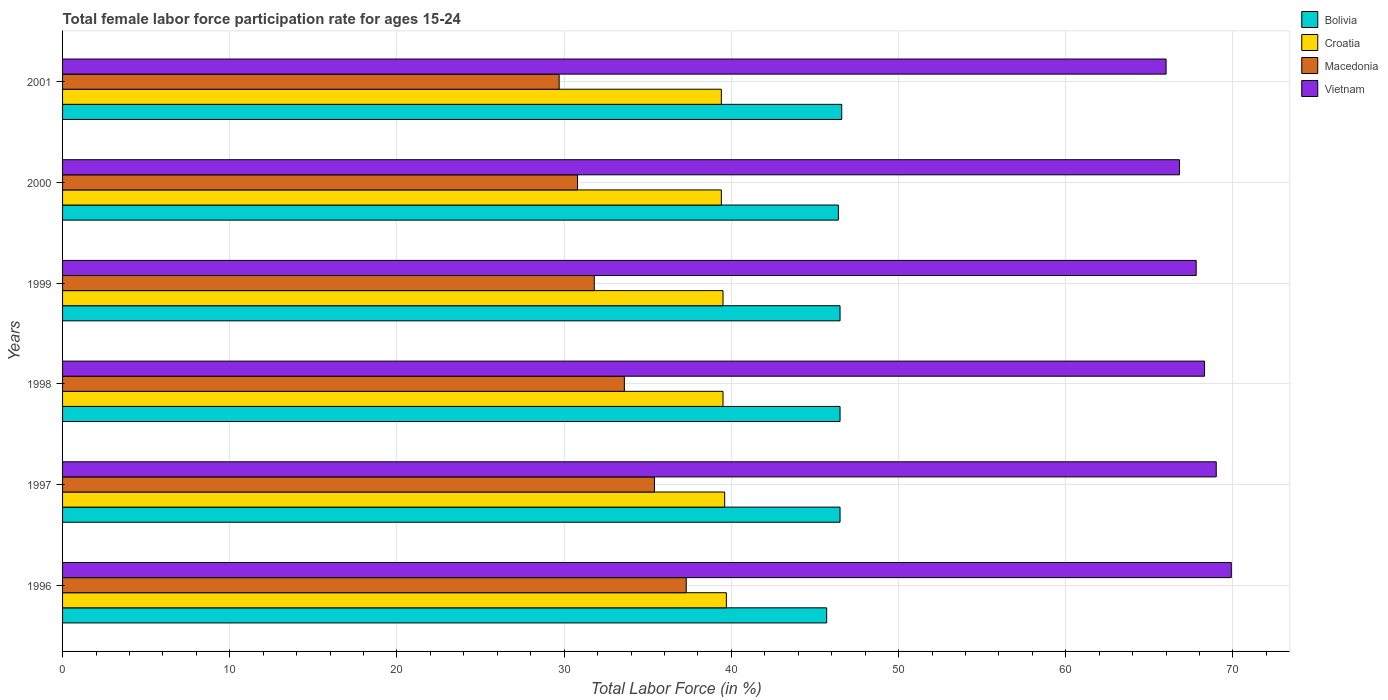How many groups of bars are there?
Provide a short and direct response. 6. Are the number of bars per tick equal to the number of legend labels?
Your answer should be compact. Yes. Are the number of bars on each tick of the Y-axis equal?
Offer a terse response. Yes. What is the female labor force participation rate in Macedonia in 1998?
Offer a very short reply. 33.6. Across all years, what is the maximum female labor force participation rate in Bolivia?
Offer a very short reply. 46.6. Across all years, what is the minimum female labor force participation rate in Bolivia?
Give a very brief answer. 45.7. In which year was the female labor force participation rate in Bolivia minimum?
Your response must be concise. 1996. What is the total female labor force participation rate in Vietnam in the graph?
Offer a very short reply. 407.8. What is the difference between the female labor force participation rate in Vietnam in 1997 and that in 2000?
Give a very brief answer. 2.2. What is the difference between the female labor force participation rate in Macedonia in 1997 and the female labor force participation rate in Bolivia in 1998?
Offer a terse response. -11.1. What is the average female labor force participation rate in Bolivia per year?
Offer a very short reply. 46.37. In the year 2000, what is the difference between the female labor force participation rate in Macedonia and female labor force participation rate in Bolivia?
Make the answer very short. -15.6. What is the ratio of the female labor force participation rate in Vietnam in 1997 to that in 1998?
Provide a succinct answer. 1.01. What is the difference between the highest and the second highest female labor force participation rate in Macedonia?
Give a very brief answer. 1.9. What is the difference between the highest and the lowest female labor force participation rate in Vietnam?
Provide a short and direct response. 3.9. In how many years, is the female labor force participation rate in Croatia greater than the average female labor force participation rate in Croatia taken over all years?
Provide a short and direct response. 2. Is the sum of the female labor force participation rate in Vietnam in 1996 and 1999 greater than the maximum female labor force participation rate in Macedonia across all years?
Offer a terse response. Yes. Is it the case that in every year, the sum of the female labor force participation rate in Bolivia and female labor force participation rate in Macedonia is greater than the sum of female labor force participation rate in Croatia and female labor force participation rate in Vietnam?
Keep it short and to the point. No. What does the 1st bar from the top in 1999 represents?
Provide a short and direct response. Vietnam. What does the 3rd bar from the bottom in 1996 represents?
Keep it short and to the point. Macedonia. How many bars are there?
Your answer should be very brief. 24. Are all the bars in the graph horizontal?
Provide a succinct answer. Yes. What is the difference between two consecutive major ticks on the X-axis?
Your response must be concise. 10. What is the title of the graph?
Offer a terse response. Total female labor force participation rate for ages 15-24. What is the label or title of the Y-axis?
Your response must be concise. Years. What is the Total Labor Force (in %) of Bolivia in 1996?
Your response must be concise. 45.7. What is the Total Labor Force (in %) of Croatia in 1996?
Make the answer very short. 39.7. What is the Total Labor Force (in %) in Macedonia in 1996?
Offer a very short reply. 37.3. What is the Total Labor Force (in %) of Vietnam in 1996?
Offer a very short reply. 69.9. What is the Total Labor Force (in %) of Bolivia in 1997?
Your answer should be compact. 46.5. What is the Total Labor Force (in %) of Croatia in 1997?
Your answer should be compact. 39.6. What is the Total Labor Force (in %) of Macedonia in 1997?
Your response must be concise. 35.4. What is the Total Labor Force (in %) of Vietnam in 1997?
Offer a terse response. 69. What is the Total Labor Force (in %) of Bolivia in 1998?
Provide a short and direct response. 46.5. What is the Total Labor Force (in %) in Croatia in 1998?
Keep it short and to the point. 39.5. What is the Total Labor Force (in %) in Macedonia in 1998?
Provide a short and direct response. 33.6. What is the Total Labor Force (in %) in Vietnam in 1998?
Your answer should be very brief. 68.3. What is the Total Labor Force (in %) in Bolivia in 1999?
Provide a succinct answer. 46.5. What is the Total Labor Force (in %) in Croatia in 1999?
Keep it short and to the point. 39.5. What is the Total Labor Force (in %) in Macedonia in 1999?
Your answer should be very brief. 31.8. What is the Total Labor Force (in %) of Vietnam in 1999?
Your answer should be very brief. 67.8. What is the Total Labor Force (in %) of Bolivia in 2000?
Give a very brief answer. 46.4. What is the Total Labor Force (in %) of Croatia in 2000?
Give a very brief answer. 39.4. What is the Total Labor Force (in %) in Macedonia in 2000?
Your answer should be very brief. 30.8. What is the Total Labor Force (in %) of Vietnam in 2000?
Offer a terse response. 66.8. What is the Total Labor Force (in %) in Bolivia in 2001?
Your answer should be very brief. 46.6. What is the Total Labor Force (in %) of Croatia in 2001?
Make the answer very short. 39.4. What is the Total Labor Force (in %) in Macedonia in 2001?
Offer a very short reply. 29.7. Across all years, what is the maximum Total Labor Force (in %) of Bolivia?
Provide a succinct answer. 46.6. Across all years, what is the maximum Total Labor Force (in %) in Croatia?
Make the answer very short. 39.7. Across all years, what is the maximum Total Labor Force (in %) in Macedonia?
Give a very brief answer. 37.3. Across all years, what is the maximum Total Labor Force (in %) of Vietnam?
Your answer should be very brief. 69.9. Across all years, what is the minimum Total Labor Force (in %) of Bolivia?
Offer a very short reply. 45.7. Across all years, what is the minimum Total Labor Force (in %) in Croatia?
Offer a very short reply. 39.4. Across all years, what is the minimum Total Labor Force (in %) in Macedonia?
Give a very brief answer. 29.7. Across all years, what is the minimum Total Labor Force (in %) in Vietnam?
Provide a succinct answer. 66. What is the total Total Labor Force (in %) of Bolivia in the graph?
Your answer should be compact. 278.2. What is the total Total Labor Force (in %) in Croatia in the graph?
Ensure brevity in your answer.  237.1. What is the total Total Labor Force (in %) of Macedonia in the graph?
Offer a terse response. 198.6. What is the total Total Labor Force (in %) of Vietnam in the graph?
Ensure brevity in your answer.  407.8. What is the difference between the Total Labor Force (in %) of Bolivia in 1996 and that in 1997?
Give a very brief answer. -0.8. What is the difference between the Total Labor Force (in %) of Croatia in 1996 and that in 1997?
Keep it short and to the point. 0.1. What is the difference between the Total Labor Force (in %) of Bolivia in 1996 and that in 1998?
Ensure brevity in your answer.  -0.8. What is the difference between the Total Labor Force (in %) in Croatia in 1996 and that in 1999?
Provide a short and direct response. 0.2. What is the difference between the Total Labor Force (in %) of Macedonia in 1996 and that in 1999?
Your answer should be very brief. 5.5. What is the difference between the Total Labor Force (in %) in Bolivia in 1996 and that in 2000?
Give a very brief answer. -0.7. What is the difference between the Total Labor Force (in %) in Croatia in 1996 and that in 2000?
Make the answer very short. 0.3. What is the difference between the Total Labor Force (in %) in Macedonia in 1996 and that in 2000?
Provide a succinct answer. 6.5. What is the difference between the Total Labor Force (in %) in Vietnam in 1996 and that in 2000?
Give a very brief answer. 3.1. What is the difference between the Total Labor Force (in %) in Bolivia in 1996 and that in 2001?
Keep it short and to the point. -0.9. What is the difference between the Total Labor Force (in %) of Croatia in 1997 and that in 1998?
Offer a terse response. 0.1. What is the difference between the Total Labor Force (in %) in Vietnam in 1997 and that in 1998?
Offer a very short reply. 0.7. What is the difference between the Total Labor Force (in %) of Bolivia in 1997 and that in 1999?
Your response must be concise. 0. What is the difference between the Total Labor Force (in %) in Croatia in 1997 and that in 1999?
Your answer should be very brief. 0.1. What is the difference between the Total Labor Force (in %) of Macedonia in 1997 and that in 1999?
Make the answer very short. 3.6. What is the difference between the Total Labor Force (in %) in Vietnam in 1997 and that in 2000?
Offer a very short reply. 2.2. What is the difference between the Total Labor Force (in %) of Bolivia in 1997 and that in 2001?
Keep it short and to the point. -0.1. What is the difference between the Total Labor Force (in %) in Croatia in 1997 and that in 2001?
Make the answer very short. 0.2. What is the difference between the Total Labor Force (in %) of Macedonia in 1997 and that in 2001?
Keep it short and to the point. 5.7. What is the difference between the Total Labor Force (in %) of Croatia in 1998 and that in 1999?
Provide a succinct answer. 0. What is the difference between the Total Labor Force (in %) in Macedonia in 1998 and that in 1999?
Ensure brevity in your answer.  1.8. What is the difference between the Total Labor Force (in %) in Vietnam in 1998 and that in 1999?
Keep it short and to the point. 0.5. What is the difference between the Total Labor Force (in %) in Bolivia in 1998 and that in 2001?
Offer a very short reply. -0.1. What is the difference between the Total Labor Force (in %) in Croatia in 1998 and that in 2001?
Give a very brief answer. 0.1. What is the difference between the Total Labor Force (in %) in Bolivia in 1999 and that in 2000?
Keep it short and to the point. 0.1. What is the difference between the Total Labor Force (in %) in Macedonia in 1999 and that in 2000?
Ensure brevity in your answer.  1. What is the difference between the Total Labor Force (in %) of Vietnam in 1999 and that in 2000?
Provide a short and direct response. 1. What is the difference between the Total Labor Force (in %) in Croatia in 2000 and that in 2001?
Make the answer very short. 0. What is the difference between the Total Labor Force (in %) of Macedonia in 2000 and that in 2001?
Your response must be concise. 1.1. What is the difference between the Total Labor Force (in %) of Bolivia in 1996 and the Total Labor Force (in %) of Vietnam in 1997?
Provide a short and direct response. -23.3. What is the difference between the Total Labor Force (in %) of Croatia in 1996 and the Total Labor Force (in %) of Macedonia in 1997?
Make the answer very short. 4.3. What is the difference between the Total Labor Force (in %) in Croatia in 1996 and the Total Labor Force (in %) in Vietnam in 1997?
Give a very brief answer. -29.3. What is the difference between the Total Labor Force (in %) of Macedonia in 1996 and the Total Labor Force (in %) of Vietnam in 1997?
Your answer should be very brief. -31.7. What is the difference between the Total Labor Force (in %) of Bolivia in 1996 and the Total Labor Force (in %) of Croatia in 1998?
Give a very brief answer. 6.2. What is the difference between the Total Labor Force (in %) in Bolivia in 1996 and the Total Labor Force (in %) in Vietnam in 1998?
Offer a very short reply. -22.6. What is the difference between the Total Labor Force (in %) of Croatia in 1996 and the Total Labor Force (in %) of Vietnam in 1998?
Keep it short and to the point. -28.6. What is the difference between the Total Labor Force (in %) in Macedonia in 1996 and the Total Labor Force (in %) in Vietnam in 1998?
Your response must be concise. -31. What is the difference between the Total Labor Force (in %) of Bolivia in 1996 and the Total Labor Force (in %) of Macedonia in 1999?
Your answer should be very brief. 13.9. What is the difference between the Total Labor Force (in %) in Bolivia in 1996 and the Total Labor Force (in %) in Vietnam in 1999?
Provide a short and direct response. -22.1. What is the difference between the Total Labor Force (in %) of Croatia in 1996 and the Total Labor Force (in %) of Vietnam in 1999?
Provide a succinct answer. -28.1. What is the difference between the Total Labor Force (in %) of Macedonia in 1996 and the Total Labor Force (in %) of Vietnam in 1999?
Your response must be concise. -30.5. What is the difference between the Total Labor Force (in %) in Bolivia in 1996 and the Total Labor Force (in %) in Croatia in 2000?
Offer a very short reply. 6.3. What is the difference between the Total Labor Force (in %) in Bolivia in 1996 and the Total Labor Force (in %) in Macedonia in 2000?
Provide a short and direct response. 14.9. What is the difference between the Total Labor Force (in %) of Bolivia in 1996 and the Total Labor Force (in %) of Vietnam in 2000?
Offer a very short reply. -21.1. What is the difference between the Total Labor Force (in %) of Croatia in 1996 and the Total Labor Force (in %) of Vietnam in 2000?
Provide a short and direct response. -27.1. What is the difference between the Total Labor Force (in %) of Macedonia in 1996 and the Total Labor Force (in %) of Vietnam in 2000?
Provide a succinct answer. -29.5. What is the difference between the Total Labor Force (in %) in Bolivia in 1996 and the Total Labor Force (in %) in Croatia in 2001?
Provide a succinct answer. 6.3. What is the difference between the Total Labor Force (in %) in Bolivia in 1996 and the Total Labor Force (in %) in Macedonia in 2001?
Provide a succinct answer. 16. What is the difference between the Total Labor Force (in %) of Bolivia in 1996 and the Total Labor Force (in %) of Vietnam in 2001?
Your answer should be compact. -20.3. What is the difference between the Total Labor Force (in %) of Croatia in 1996 and the Total Labor Force (in %) of Macedonia in 2001?
Ensure brevity in your answer.  10. What is the difference between the Total Labor Force (in %) in Croatia in 1996 and the Total Labor Force (in %) in Vietnam in 2001?
Keep it short and to the point. -26.3. What is the difference between the Total Labor Force (in %) of Macedonia in 1996 and the Total Labor Force (in %) of Vietnam in 2001?
Your answer should be very brief. -28.7. What is the difference between the Total Labor Force (in %) in Bolivia in 1997 and the Total Labor Force (in %) in Vietnam in 1998?
Ensure brevity in your answer.  -21.8. What is the difference between the Total Labor Force (in %) in Croatia in 1997 and the Total Labor Force (in %) in Vietnam in 1998?
Provide a short and direct response. -28.7. What is the difference between the Total Labor Force (in %) of Macedonia in 1997 and the Total Labor Force (in %) of Vietnam in 1998?
Offer a very short reply. -32.9. What is the difference between the Total Labor Force (in %) of Bolivia in 1997 and the Total Labor Force (in %) of Croatia in 1999?
Offer a terse response. 7. What is the difference between the Total Labor Force (in %) in Bolivia in 1997 and the Total Labor Force (in %) in Macedonia in 1999?
Your response must be concise. 14.7. What is the difference between the Total Labor Force (in %) in Bolivia in 1997 and the Total Labor Force (in %) in Vietnam in 1999?
Give a very brief answer. -21.3. What is the difference between the Total Labor Force (in %) of Croatia in 1997 and the Total Labor Force (in %) of Vietnam in 1999?
Provide a short and direct response. -28.2. What is the difference between the Total Labor Force (in %) of Macedonia in 1997 and the Total Labor Force (in %) of Vietnam in 1999?
Give a very brief answer. -32.4. What is the difference between the Total Labor Force (in %) in Bolivia in 1997 and the Total Labor Force (in %) in Macedonia in 2000?
Your response must be concise. 15.7. What is the difference between the Total Labor Force (in %) in Bolivia in 1997 and the Total Labor Force (in %) in Vietnam in 2000?
Provide a succinct answer. -20.3. What is the difference between the Total Labor Force (in %) of Croatia in 1997 and the Total Labor Force (in %) of Macedonia in 2000?
Your answer should be very brief. 8.8. What is the difference between the Total Labor Force (in %) of Croatia in 1997 and the Total Labor Force (in %) of Vietnam in 2000?
Keep it short and to the point. -27.2. What is the difference between the Total Labor Force (in %) of Macedonia in 1997 and the Total Labor Force (in %) of Vietnam in 2000?
Keep it short and to the point. -31.4. What is the difference between the Total Labor Force (in %) of Bolivia in 1997 and the Total Labor Force (in %) of Croatia in 2001?
Provide a succinct answer. 7.1. What is the difference between the Total Labor Force (in %) of Bolivia in 1997 and the Total Labor Force (in %) of Macedonia in 2001?
Keep it short and to the point. 16.8. What is the difference between the Total Labor Force (in %) in Bolivia in 1997 and the Total Labor Force (in %) in Vietnam in 2001?
Ensure brevity in your answer.  -19.5. What is the difference between the Total Labor Force (in %) in Croatia in 1997 and the Total Labor Force (in %) in Macedonia in 2001?
Keep it short and to the point. 9.9. What is the difference between the Total Labor Force (in %) of Croatia in 1997 and the Total Labor Force (in %) of Vietnam in 2001?
Provide a short and direct response. -26.4. What is the difference between the Total Labor Force (in %) of Macedonia in 1997 and the Total Labor Force (in %) of Vietnam in 2001?
Your response must be concise. -30.6. What is the difference between the Total Labor Force (in %) of Bolivia in 1998 and the Total Labor Force (in %) of Croatia in 1999?
Your response must be concise. 7. What is the difference between the Total Labor Force (in %) of Bolivia in 1998 and the Total Labor Force (in %) of Macedonia in 1999?
Make the answer very short. 14.7. What is the difference between the Total Labor Force (in %) of Bolivia in 1998 and the Total Labor Force (in %) of Vietnam in 1999?
Provide a succinct answer. -21.3. What is the difference between the Total Labor Force (in %) of Croatia in 1998 and the Total Labor Force (in %) of Macedonia in 1999?
Make the answer very short. 7.7. What is the difference between the Total Labor Force (in %) in Croatia in 1998 and the Total Labor Force (in %) in Vietnam in 1999?
Give a very brief answer. -28.3. What is the difference between the Total Labor Force (in %) of Macedonia in 1998 and the Total Labor Force (in %) of Vietnam in 1999?
Give a very brief answer. -34.2. What is the difference between the Total Labor Force (in %) in Bolivia in 1998 and the Total Labor Force (in %) in Croatia in 2000?
Your response must be concise. 7.1. What is the difference between the Total Labor Force (in %) of Bolivia in 1998 and the Total Labor Force (in %) of Vietnam in 2000?
Make the answer very short. -20.3. What is the difference between the Total Labor Force (in %) of Croatia in 1998 and the Total Labor Force (in %) of Vietnam in 2000?
Offer a terse response. -27.3. What is the difference between the Total Labor Force (in %) of Macedonia in 1998 and the Total Labor Force (in %) of Vietnam in 2000?
Keep it short and to the point. -33.2. What is the difference between the Total Labor Force (in %) in Bolivia in 1998 and the Total Labor Force (in %) in Macedonia in 2001?
Offer a terse response. 16.8. What is the difference between the Total Labor Force (in %) in Bolivia in 1998 and the Total Labor Force (in %) in Vietnam in 2001?
Offer a very short reply. -19.5. What is the difference between the Total Labor Force (in %) in Croatia in 1998 and the Total Labor Force (in %) in Macedonia in 2001?
Provide a succinct answer. 9.8. What is the difference between the Total Labor Force (in %) of Croatia in 1998 and the Total Labor Force (in %) of Vietnam in 2001?
Provide a short and direct response. -26.5. What is the difference between the Total Labor Force (in %) in Macedonia in 1998 and the Total Labor Force (in %) in Vietnam in 2001?
Your answer should be compact. -32.4. What is the difference between the Total Labor Force (in %) in Bolivia in 1999 and the Total Labor Force (in %) in Croatia in 2000?
Offer a terse response. 7.1. What is the difference between the Total Labor Force (in %) of Bolivia in 1999 and the Total Labor Force (in %) of Macedonia in 2000?
Provide a succinct answer. 15.7. What is the difference between the Total Labor Force (in %) of Bolivia in 1999 and the Total Labor Force (in %) of Vietnam in 2000?
Offer a terse response. -20.3. What is the difference between the Total Labor Force (in %) of Croatia in 1999 and the Total Labor Force (in %) of Macedonia in 2000?
Keep it short and to the point. 8.7. What is the difference between the Total Labor Force (in %) of Croatia in 1999 and the Total Labor Force (in %) of Vietnam in 2000?
Give a very brief answer. -27.3. What is the difference between the Total Labor Force (in %) of Macedonia in 1999 and the Total Labor Force (in %) of Vietnam in 2000?
Your response must be concise. -35. What is the difference between the Total Labor Force (in %) of Bolivia in 1999 and the Total Labor Force (in %) of Vietnam in 2001?
Your response must be concise. -19.5. What is the difference between the Total Labor Force (in %) of Croatia in 1999 and the Total Labor Force (in %) of Vietnam in 2001?
Your response must be concise. -26.5. What is the difference between the Total Labor Force (in %) of Macedonia in 1999 and the Total Labor Force (in %) of Vietnam in 2001?
Provide a short and direct response. -34.2. What is the difference between the Total Labor Force (in %) in Bolivia in 2000 and the Total Labor Force (in %) in Macedonia in 2001?
Offer a very short reply. 16.7. What is the difference between the Total Labor Force (in %) in Bolivia in 2000 and the Total Labor Force (in %) in Vietnam in 2001?
Keep it short and to the point. -19.6. What is the difference between the Total Labor Force (in %) of Croatia in 2000 and the Total Labor Force (in %) of Macedonia in 2001?
Your answer should be very brief. 9.7. What is the difference between the Total Labor Force (in %) in Croatia in 2000 and the Total Labor Force (in %) in Vietnam in 2001?
Make the answer very short. -26.6. What is the difference between the Total Labor Force (in %) in Macedonia in 2000 and the Total Labor Force (in %) in Vietnam in 2001?
Give a very brief answer. -35.2. What is the average Total Labor Force (in %) in Bolivia per year?
Give a very brief answer. 46.37. What is the average Total Labor Force (in %) of Croatia per year?
Give a very brief answer. 39.52. What is the average Total Labor Force (in %) of Macedonia per year?
Provide a short and direct response. 33.1. What is the average Total Labor Force (in %) of Vietnam per year?
Offer a terse response. 67.97. In the year 1996, what is the difference between the Total Labor Force (in %) of Bolivia and Total Labor Force (in %) of Macedonia?
Offer a terse response. 8.4. In the year 1996, what is the difference between the Total Labor Force (in %) in Bolivia and Total Labor Force (in %) in Vietnam?
Your response must be concise. -24.2. In the year 1996, what is the difference between the Total Labor Force (in %) in Croatia and Total Labor Force (in %) in Vietnam?
Offer a very short reply. -30.2. In the year 1996, what is the difference between the Total Labor Force (in %) of Macedonia and Total Labor Force (in %) of Vietnam?
Your response must be concise. -32.6. In the year 1997, what is the difference between the Total Labor Force (in %) in Bolivia and Total Labor Force (in %) in Vietnam?
Your answer should be compact. -22.5. In the year 1997, what is the difference between the Total Labor Force (in %) of Croatia and Total Labor Force (in %) of Macedonia?
Offer a very short reply. 4.2. In the year 1997, what is the difference between the Total Labor Force (in %) in Croatia and Total Labor Force (in %) in Vietnam?
Keep it short and to the point. -29.4. In the year 1997, what is the difference between the Total Labor Force (in %) in Macedonia and Total Labor Force (in %) in Vietnam?
Ensure brevity in your answer.  -33.6. In the year 1998, what is the difference between the Total Labor Force (in %) in Bolivia and Total Labor Force (in %) in Vietnam?
Make the answer very short. -21.8. In the year 1998, what is the difference between the Total Labor Force (in %) in Croatia and Total Labor Force (in %) in Vietnam?
Provide a succinct answer. -28.8. In the year 1998, what is the difference between the Total Labor Force (in %) of Macedonia and Total Labor Force (in %) of Vietnam?
Offer a very short reply. -34.7. In the year 1999, what is the difference between the Total Labor Force (in %) in Bolivia and Total Labor Force (in %) in Croatia?
Keep it short and to the point. 7. In the year 1999, what is the difference between the Total Labor Force (in %) in Bolivia and Total Labor Force (in %) in Macedonia?
Provide a succinct answer. 14.7. In the year 1999, what is the difference between the Total Labor Force (in %) in Bolivia and Total Labor Force (in %) in Vietnam?
Make the answer very short. -21.3. In the year 1999, what is the difference between the Total Labor Force (in %) of Croatia and Total Labor Force (in %) of Macedonia?
Provide a succinct answer. 7.7. In the year 1999, what is the difference between the Total Labor Force (in %) in Croatia and Total Labor Force (in %) in Vietnam?
Your answer should be very brief. -28.3. In the year 1999, what is the difference between the Total Labor Force (in %) in Macedonia and Total Labor Force (in %) in Vietnam?
Your answer should be very brief. -36. In the year 2000, what is the difference between the Total Labor Force (in %) of Bolivia and Total Labor Force (in %) of Vietnam?
Ensure brevity in your answer.  -20.4. In the year 2000, what is the difference between the Total Labor Force (in %) in Croatia and Total Labor Force (in %) in Macedonia?
Make the answer very short. 8.6. In the year 2000, what is the difference between the Total Labor Force (in %) of Croatia and Total Labor Force (in %) of Vietnam?
Your response must be concise. -27.4. In the year 2000, what is the difference between the Total Labor Force (in %) of Macedonia and Total Labor Force (in %) of Vietnam?
Keep it short and to the point. -36. In the year 2001, what is the difference between the Total Labor Force (in %) in Bolivia and Total Labor Force (in %) in Macedonia?
Provide a succinct answer. 16.9. In the year 2001, what is the difference between the Total Labor Force (in %) of Bolivia and Total Labor Force (in %) of Vietnam?
Keep it short and to the point. -19.4. In the year 2001, what is the difference between the Total Labor Force (in %) of Croatia and Total Labor Force (in %) of Vietnam?
Offer a terse response. -26.6. In the year 2001, what is the difference between the Total Labor Force (in %) of Macedonia and Total Labor Force (in %) of Vietnam?
Ensure brevity in your answer.  -36.3. What is the ratio of the Total Labor Force (in %) of Bolivia in 1996 to that in 1997?
Ensure brevity in your answer.  0.98. What is the ratio of the Total Labor Force (in %) in Macedonia in 1996 to that in 1997?
Offer a terse response. 1.05. What is the ratio of the Total Labor Force (in %) of Vietnam in 1996 to that in 1997?
Provide a short and direct response. 1.01. What is the ratio of the Total Labor Force (in %) in Bolivia in 1996 to that in 1998?
Offer a terse response. 0.98. What is the ratio of the Total Labor Force (in %) in Macedonia in 1996 to that in 1998?
Your answer should be compact. 1.11. What is the ratio of the Total Labor Force (in %) in Vietnam in 1996 to that in 1998?
Your answer should be very brief. 1.02. What is the ratio of the Total Labor Force (in %) in Bolivia in 1996 to that in 1999?
Keep it short and to the point. 0.98. What is the ratio of the Total Labor Force (in %) of Croatia in 1996 to that in 1999?
Provide a short and direct response. 1.01. What is the ratio of the Total Labor Force (in %) of Macedonia in 1996 to that in 1999?
Your answer should be very brief. 1.17. What is the ratio of the Total Labor Force (in %) in Vietnam in 1996 to that in 1999?
Make the answer very short. 1.03. What is the ratio of the Total Labor Force (in %) of Bolivia in 1996 to that in 2000?
Make the answer very short. 0.98. What is the ratio of the Total Labor Force (in %) in Croatia in 1996 to that in 2000?
Your answer should be compact. 1.01. What is the ratio of the Total Labor Force (in %) in Macedonia in 1996 to that in 2000?
Make the answer very short. 1.21. What is the ratio of the Total Labor Force (in %) in Vietnam in 1996 to that in 2000?
Ensure brevity in your answer.  1.05. What is the ratio of the Total Labor Force (in %) in Bolivia in 1996 to that in 2001?
Keep it short and to the point. 0.98. What is the ratio of the Total Labor Force (in %) of Croatia in 1996 to that in 2001?
Offer a terse response. 1.01. What is the ratio of the Total Labor Force (in %) of Macedonia in 1996 to that in 2001?
Keep it short and to the point. 1.26. What is the ratio of the Total Labor Force (in %) of Vietnam in 1996 to that in 2001?
Your answer should be very brief. 1.06. What is the ratio of the Total Labor Force (in %) in Bolivia in 1997 to that in 1998?
Your answer should be compact. 1. What is the ratio of the Total Labor Force (in %) of Croatia in 1997 to that in 1998?
Keep it short and to the point. 1. What is the ratio of the Total Labor Force (in %) in Macedonia in 1997 to that in 1998?
Give a very brief answer. 1.05. What is the ratio of the Total Labor Force (in %) in Vietnam in 1997 to that in 1998?
Make the answer very short. 1.01. What is the ratio of the Total Labor Force (in %) of Croatia in 1997 to that in 1999?
Offer a very short reply. 1. What is the ratio of the Total Labor Force (in %) in Macedonia in 1997 to that in 1999?
Your answer should be compact. 1.11. What is the ratio of the Total Labor Force (in %) of Vietnam in 1997 to that in 1999?
Give a very brief answer. 1.02. What is the ratio of the Total Labor Force (in %) of Bolivia in 1997 to that in 2000?
Give a very brief answer. 1. What is the ratio of the Total Labor Force (in %) in Croatia in 1997 to that in 2000?
Provide a short and direct response. 1.01. What is the ratio of the Total Labor Force (in %) of Macedonia in 1997 to that in 2000?
Provide a succinct answer. 1.15. What is the ratio of the Total Labor Force (in %) of Vietnam in 1997 to that in 2000?
Your response must be concise. 1.03. What is the ratio of the Total Labor Force (in %) of Croatia in 1997 to that in 2001?
Your answer should be compact. 1.01. What is the ratio of the Total Labor Force (in %) of Macedonia in 1997 to that in 2001?
Offer a terse response. 1.19. What is the ratio of the Total Labor Force (in %) of Vietnam in 1997 to that in 2001?
Offer a very short reply. 1.05. What is the ratio of the Total Labor Force (in %) in Bolivia in 1998 to that in 1999?
Offer a very short reply. 1. What is the ratio of the Total Labor Force (in %) of Croatia in 1998 to that in 1999?
Make the answer very short. 1. What is the ratio of the Total Labor Force (in %) of Macedonia in 1998 to that in 1999?
Make the answer very short. 1.06. What is the ratio of the Total Labor Force (in %) in Vietnam in 1998 to that in 1999?
Offer a very short reply. 1.01. What is the ratio of the Total Labor Force (in %) of Bolivia in 1998 to that in 2000?
Make the answer very short. 1. What is the ratio of the Total Labor Force (in %) of Vietnam in 1998 to that in 2000?
Give a very brief answer. 1.02. What is the ratio of the Total Labor Force (in %) of Macedonia in 1998 to that in 2001?
Give a very brief answer. 1.13. What is the ratio of the Total Labor Force (in %) in Vietnam in 1998 to that in 2001?
Make the answer very short. 1.03. What is the ratio of the Total Labor Force (in %) of Bolivia in 1999 to that in 2000?
Your answer should be very brief. 1. What is the ratio of the Total Labor Force (in %) of Croatia in 1999 to that in 2000?
Provide a succinct answer. 1. What is the ratio of the Total Labor Force (in %) of Macedonia in 1999 to that in 2000?
Provide a short and direct response. 1.03. What is the ratio of the Total Labor Force (in %) in Vietnam in 1999 to that in 2000?
Your response must be concise. 1.01. What is the ratio of the Total Labor Force (in %) in Bolivia in 1999 to that in 2001?
Give a very brief answer. 1. What is the ratio of the Total Labor Force (in %) in Croatia in 1999 to that in 2001?
Offer a very short reply. 1. What is the ratio of the Total Labor Force (in %) in Macedonia in 1999 to that in 2001?
Your answer should be very brief. 1.07. What is the ratio of the Total Labor Force (in %) of Vietnam in 1999 to that in 2001?
Your response must be concise. 1.03. What is the ratio of the Total Labor Force (in %) of Bolivia in 2000 to that in 2001?
Provide a succinct answer. 1. What is the ratio of the Total Labor Force (in %) of Croatia in 2000 to that in 2001?
Provide a succinct answer. 1. What is the ratio of the Total Labor Force (in %) in Macedonia in 2000 to that in 2001?
Your response must be concise. 1.04. What is the ratio of the Total Labor Force (in %) in Vietnam in 2000 to that in 2001?
Make the answer very short. 1.01. What is the difference between the highest and the second highest Total Labor Force (in %) of Bolivia?
Make the answer very short. 0.1. What is the difference between the highest and the second highest Total Labor Force (in %) in Croatia?
Your answer should be compact. 0.1. What is the difference between the highest and the lowest Total Labor Force (in %) in Bolivia?
Offer a very short reply. 0.9. What is the difference between the highest and the lowest Total Labor Force (in %) of Croatia?
Provide a short and direct response. 0.3. What is the difference between the highest and the lowest Total Labor Force (in %) in Vietnam?
Offer a terse response. 3.9. 